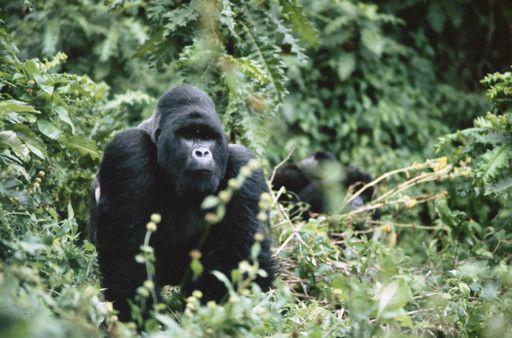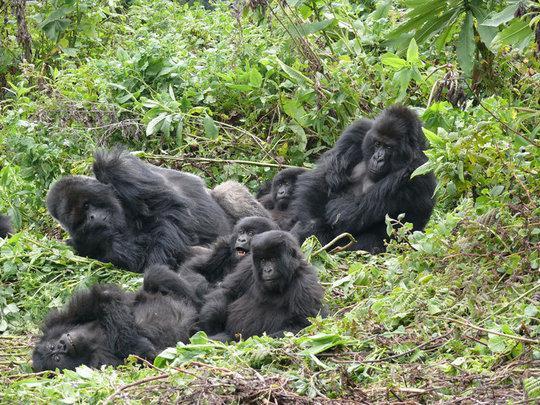The first image is the image on the left, the second image is the image on the right. For the images displayed, is the sentence "There is a single ape in the right image." factually correct? Answer yes or no. No. The first image is the image on the left, the second image is the image on the right. For the images displayed, is the sentence "The gorilla in the left image is very close to another gorilla." factually correct? Answer yes or no. No. 